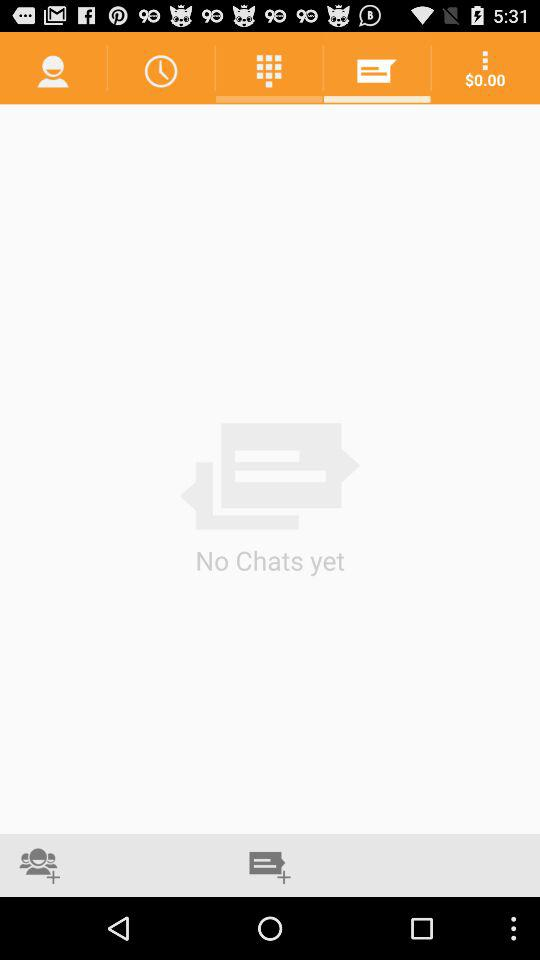How much money do I have?
Answer the question using a single word or phrase. $0.00 